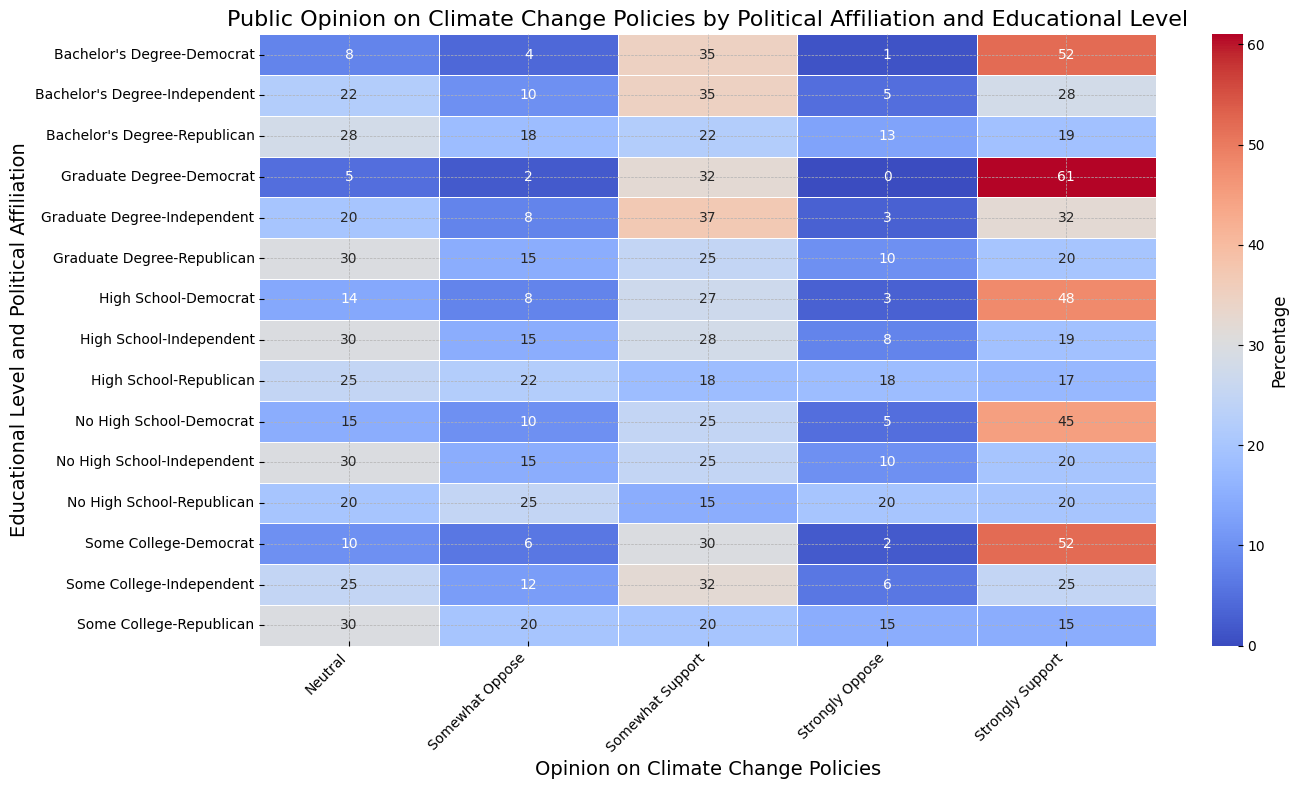What's the level of support for climate change policies among Independents with a Bachelor's degree? Look at the row labeled "Independent, Bachelor's Degree" on the heatmap and find the values for "Somewhat Support" and "Strongly Support”. Sum these two values: 35 (Somewhat Support) + 28 (Strongly Support) = 63.
Answer: 63 Do Democrats with a High School education level show stronger support for climate change policies compared to Independents with the same educational level? Compare the "Somewhat Support" and "Strongly Support" values for both groups in the "High School" category. Democrats: 27 (Somewhat Support) + 48 (Strongly Support) = 75. Independents: 28 (Somewhat Support) + 19 (Strongly Support) = 47. 75 is greater than 47.
Answer: Yes What is the average neutral stance on climate change policies among Republicans? Find the "Neutral" column values for all educational levels of Republicans and take their average. (20 + 25 + 30 + 28 + 30)/5 = 26.6.
Answer: 26.6 Which educational level among Republicans shows the least opposition (Strongly Oppose) to climate change policies? Look at the "Strongly Oppose" column for all educational levels of Republicans. The least value is 10, which corresponds to the "Graduate Degree" level.
Answer: Graduate Degree What is the color intensity for Democrats with Graduate Degrees who Strongly Support climate change policies? On the heatmap, find the cell that corresponds to "Democrat, Graduate Degree" and "Strongly Support". Notice that this value (61) will likely be among the highest and thus colored in a deeper hue, closer to the darker end of the color scale employed in the heatmap.
Answer: Dark Blue Among Republicans with some college education, is there a higher tendency to oppose or support climate change policies? Compare the sum of "Strongly Oppose" and "Somewhat Oppose" values (15 + 20 = 35) to the sum of "Somewhat Support" and "Strongly Support" values (20 + 15 = 35). The values are identical, so the tendency is equal.
Answer: Equal Do Independents with no high school education show more neutrality towards climate change policies than support? Compare the "Neutral" value (30) to the sum of "Somewhat Support" and "Strongly Support" values (25 + 20 = 45). 30 is less than 45, so they show more support.
Answer: No What proportion of Democrats with a Bachelor's Degree somewhat support climate change policies? Look at the row labeled "Democrat, Bachelor's Degree" and find the "Somewhat Support" value (35). This proportion can be directly seen as part of the educational level's opinion spread.
Answer: 35% Is the overall neutrality towards climate change policies higher for Independents or Republicans across all educational levels? Sum the "Neutral" values for each educational level within Independents (30 + 30 + 25 + 22 + 20 = 127) and Republicans (20 + 25 + 30 + 28 + 30 = 133). 127 is less than 133.
Answer: Republicans 